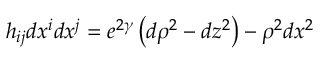Convert formula to latex. <formula><loc_0><loc_0><loc_500><loc_500>h _ { i j } d x ^ { i } d x ^ { j } = e ^ { 2 \gamma } \left ( d \rho ^ { 2 } - d z ^ { 2 } \right ) - \rho ^ { 2 } d x ^ { 2 }</formula> 